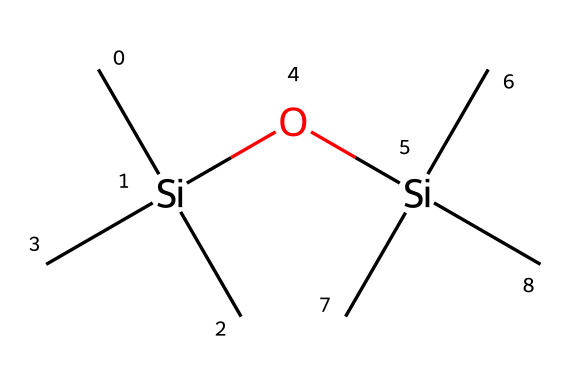What is the molecular formula of this silane? To determine the molecular formula, we count the carbon and silicon atoms in the structure represented by the SMILES. There are 6 carbon atoms and 2 silicon atoms. Consequently, the molecular formula is C6H16O2Si2.
Answer: C6H16O2Si2 How many silicon atoms are in this chemical? By analyzing the SMILES representation, we can see that there are two distinct silicon atoms present in the structure.
Answer: 2 What functional group is present in this silane? The presence of the -O- group indicates that there is an ether functional group within the structure, which is crucial for water repellency.
Answer: ether What does the arrangement of carbon atoms suggest about its properties? The arrangement of carbon atoms, particularly in a branched structure as indicated by the SMILES, suggests it may provide better hydrophobic properties, enhancing its effectiveness as a water repellent.
Answer: hydrophobic How many total atoms are in the molecular structure? To get the total atom count, we add the individual atoms: 6 carbon + 2 silicon + 1 oxygen + 1 oxygen = 10 atoms total.
Answer: 10 What type of chemical is this? Given its structure and the presence of silicon, carbon, and oxygen, this chemical is categorized as a silane derivative, specifically designed for water-repellent applications.
Answer: silane derivative 